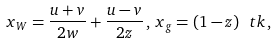Convert formula to latex. <formula><loc_0><loc_0><loc_500><loc_500>x _ { W } = \frac { u + v } { 2 w } + \frac { u - v } { 2 z } \, , \, x _ { g } = ( 1 - z ) \ t k \, ,</formula> 